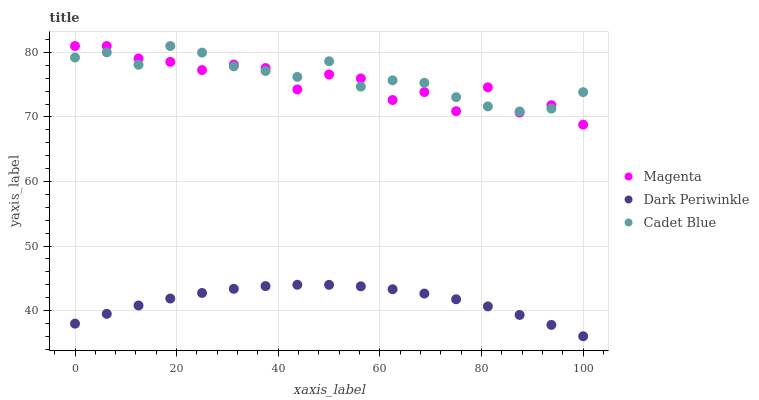Does Dark Periwinkle have the minimum area under the curve?
Answer yes or no. Yes. Does Cadet Blue have the maximum area under the curve?
Answer yes or no. Yes. Does Cadet Blue have the minimum area under the curve?
Answer yes or no. No. Does Dark Periwinkle have the maximum area under the curve?
Answer yes or no. No. Is Dark Periwinkle the smoothest?
Answer yes or no. Yes. Is Magenta the roughest?
Answer yes or no. Yes. Is Cadet Blue the smoothest?
Answer yes or no. No. Is Cadet Blue the roughest?
Answer yes or no. No. Does Dark Periwinkle have the lowest value?
Answer yes or no. Yes. Does Cadet Blue have the lowest value?
Answer yes or no. No. Does Cadet Blue have the highest value?
Answer yes or no. Yes. Does Dark Periwinkle have the highest value?
Answer yes or no. No. Is Dark Periwinkle less than Magenta?
Answer yes or no. Yes. Is Magenta greater than Dark Periwinkle?
Answer yes or no. Yes. Does Cadet Blue intersect Magenta?
Answer yes or no. Yes. Is Cadet Blue less than Magenta?
Answer yes or no. No. Is Cadet Blue greater than Magenta?
Answer yes or no. No. Does Dark Periwinkle intersect Magenta?
Answer yes or no. No. 